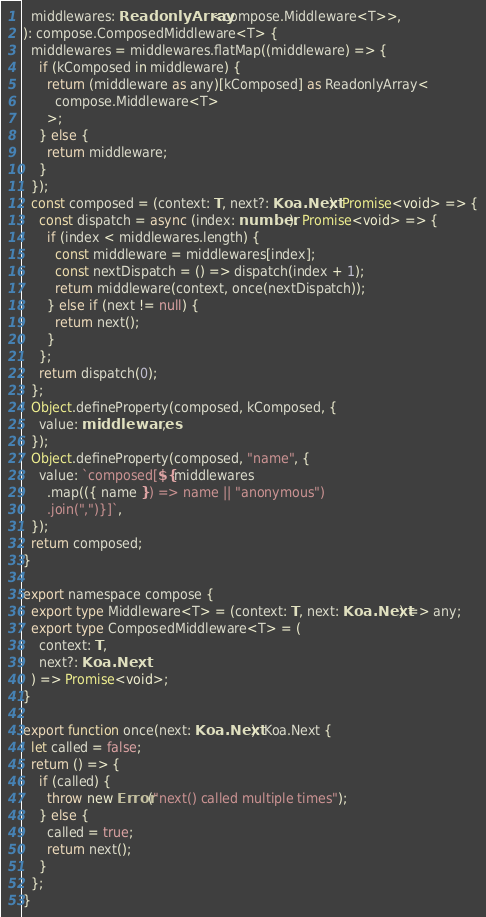Convert code to text. <code><loc_0><loc_0><loc_500><loc_500><_TypeScript_>  middlewares: ReadonlyArray<compose.Middleware<T>>,
): compose.ComposedMiddleware<T> {
  middlewares = middlewares.flatMap((middleware) => {
    if (kComposed in middleware) {
      return (middleware as any)[kComposed] as ReadonlyArray<
        compose.Middleware<T>
      >;
    } else {
      return middleware;
    }
  });
  const composed = (context: T, next?: Koa.Next): Promise<void> => {
    const dispatch = async (index: number): Promise<void> => {
      if (index < middlewares.length) {
        const middleware = middlewares[index];
        const nextDispatch = () => dispatch(index + 1);
        return middleware(context, once(nextDispatch));
      } else if (next != null) {
        return next();
      }
    };
    return dispatch(0);
  };
  Object.defineProperty(composed, kComposed, {
    value: middlewares,
  });
  Object.defineProperty(composed, "name", {
    value: `composed[${middlewares
      .map(({ name }) => name || "anonymous")
      .join(",")}]`,
  });
  return composed;
}

export namespace compose {
  export type Middleware<T> = (context: T, next: Koa.Next) => any;
  export type ComposedMiddleware<T> = (
    context: T,
    next?: Koa.Next,
  ) => Promise<void>;
}

export function once(next: Koa.Next): Koa.Next {
  let called = false;
  return () => {
    if (called) {
      throw new Error("next() called multiple times");
    } else {
      called = true;
      return next();
    }
  };
}
</code> 